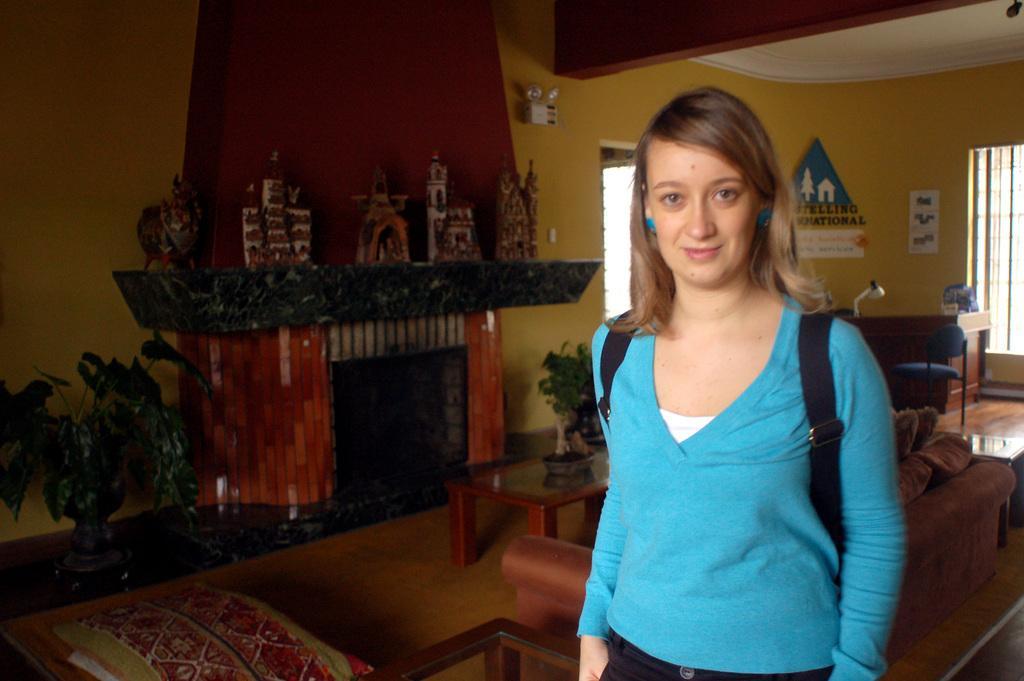Can you describe this image briefly? This image is taken indoors. In the background there is a wall with a window and a door. There are a few boards with a text on the wall. At the top right of the image there is a ceiling. On the left side of the image there is a plant in the pot. In the middle of the image there is a fireplace. There are a few objects on the wall. On the right side of the image a girl is standing. She is with a smiling face. There is a table with a reading lamp on it. There is an empty chair. There is a couch and there is another table. At the bottom of the image there is a table. There is a table with a plant on it. 